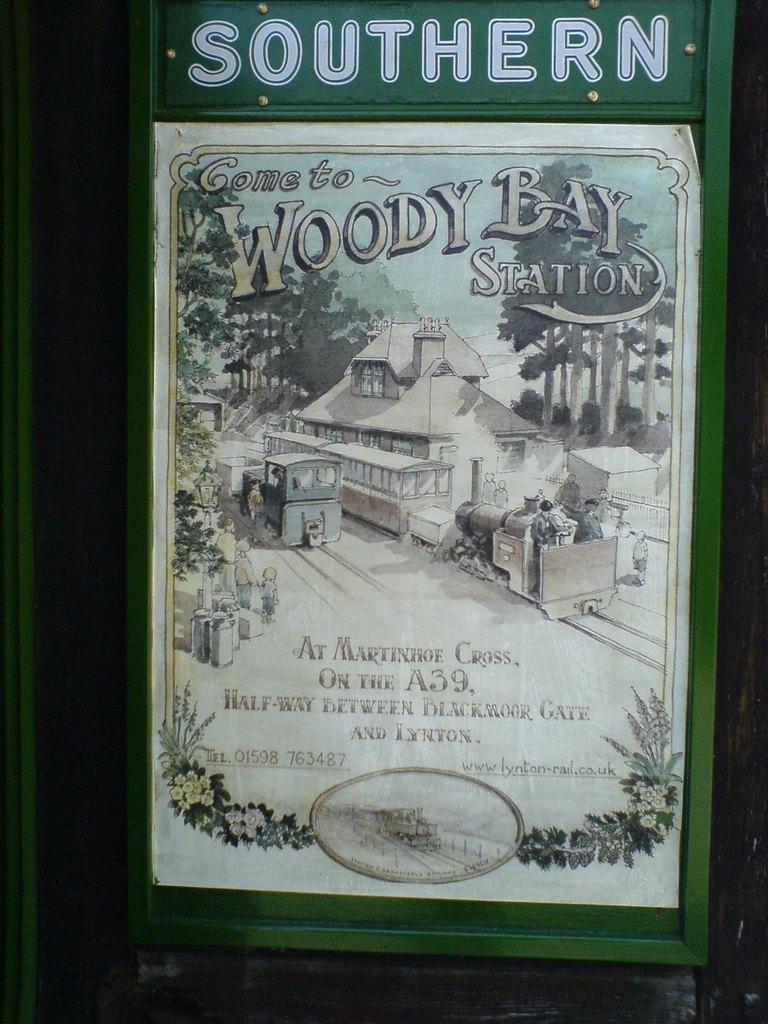Describe this image in one or two sentences. In the center of the image we can see a green color board and on the board we can see a white color text and also a paper and on the paper we can see a house, trees, text, a train with persons on the railway track. We can also see the flower designs on the paper. 